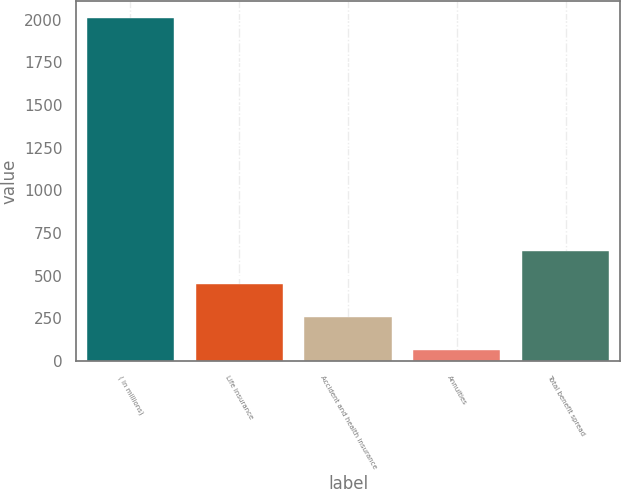<chart> <loc_0><loc_0><loc_500><loc_500><bar_chart><fcel>( in millions)<fcel>Life insurance<fcel>Accident and health insurance<fcel>Annuities<fcel>Total benefit spread<nl><fcel>2008<fcel>451.2<fcel>256.6<fcel>62<fcel>645.8<nl></chart> 